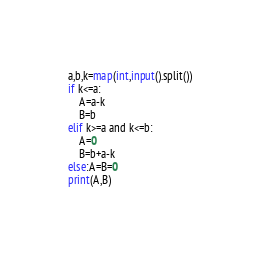Convert code to text. <code><loc_0><loc_0><loc_500><loc_500><_Python_>a,b,k=map(int,input().split())
if k<=a:
	A=a-k
	B=b
elif k>=a and k<=b:
	A=0
	B=b+a-k
else:A=B=0
print(A,B)
</code> 